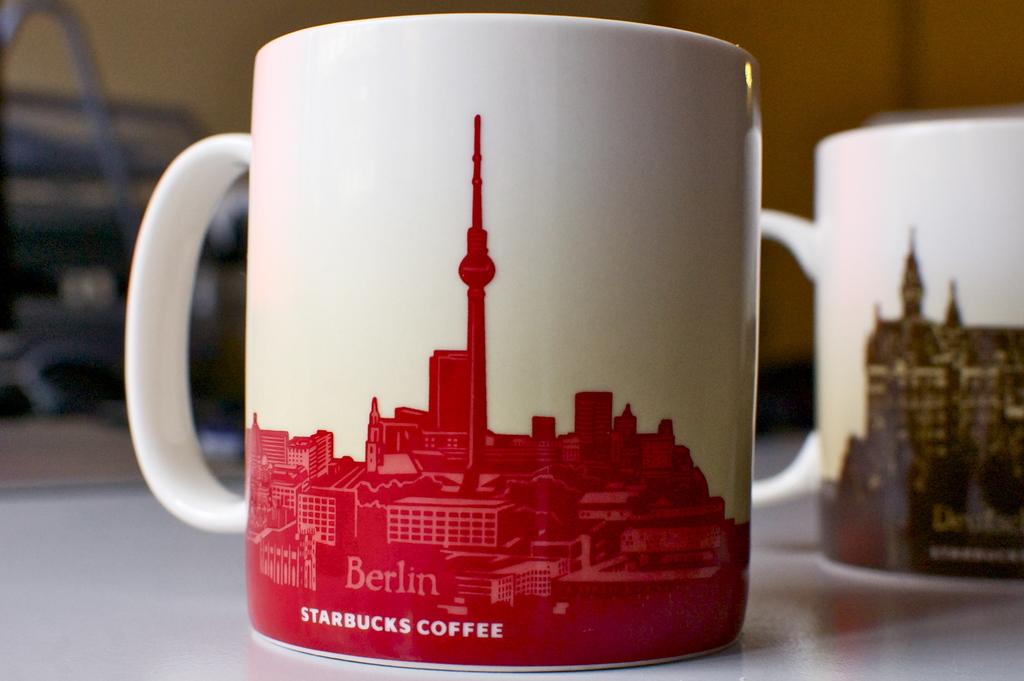Which city is shown on the mug?
Your answer should be compact. Berlin. What coffee company is written on the mug?
Give a very brief answer. Starbucks. 